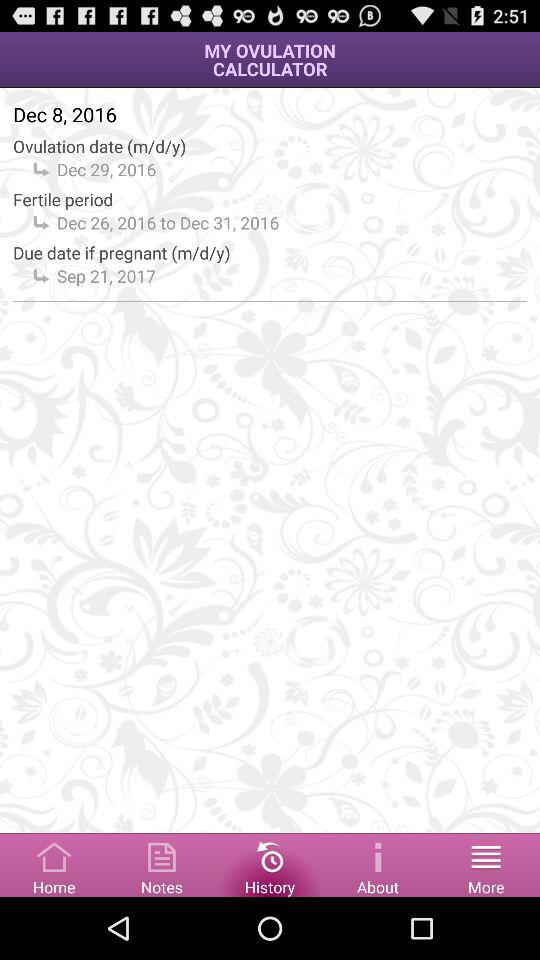What is the Ovulation date? The Ovulation date is December 29, 2016. 